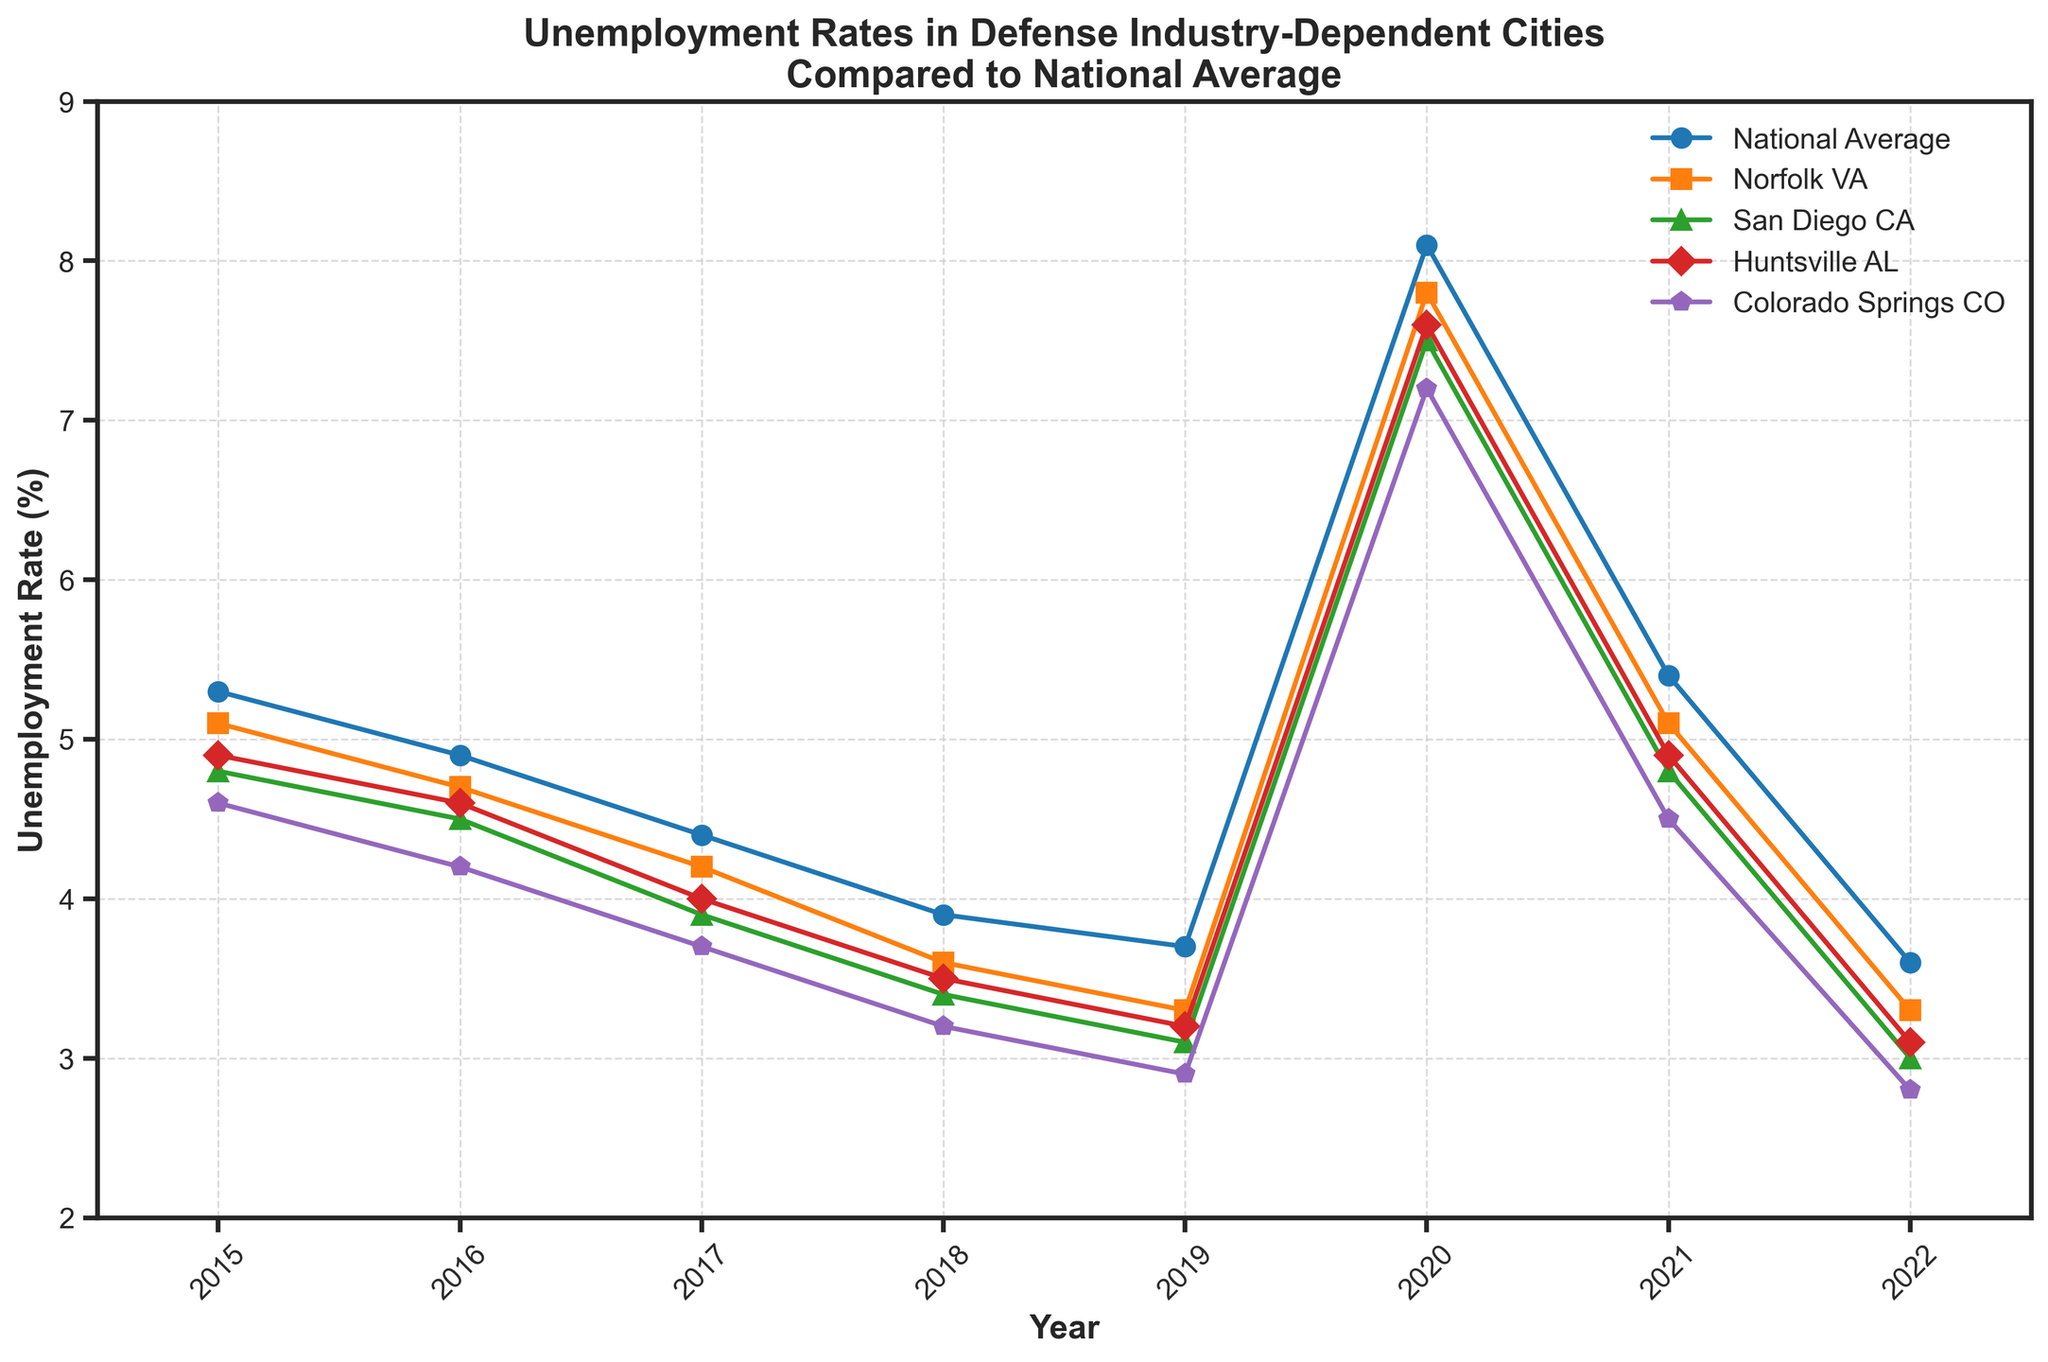What was the unemployment rate in Norfolk, VA in 2020? We look at the unemployment rate for Norfolk, VA on the year 2020 line, which shows 7.8%.
Answer: 7.8% Which city had the lowest unemployment rate in 2022? Comparing the 2022 unemployment rates for all cities, Colorado Springs, CO had the lowest at 2.8%.
Answer: Colorado Springs, CO Was the national average unemployment rate higher or lower than San Diego, CA in 2017? For 2017, the national average was 4.4% and San Diego, CA was 3.9%, so the national average was higher.
Answer: Higher What is the difference in unemployment rates between Huntsville, AL and Norfolk, VA in 2019? The unemployment rates for 2019 were 3.2% for Huntsville, AL and 3.3% for Norfolk, VA. The difference is 3.3% - 3.2% = 0.1%.
Answer: 0.1% How did the unemployment rate for Colorado Springs, CO compare to the national average in 2015? In 2015, the national average was 5.3% and the rate for Colorado Springs, CO was 4.6%. Thus, Colorado Springs, CO had a lower unemployment rate.
Answer: Lower By how much did the unemployment rate for San Diego, CA decrease from 2015 to 2022? San Diego, CA's unemployment rate was 4.8% in 2015 and 3.0% in 2022. The decrease is 4.8% - 3.0% = 1.8%.
Answer: 1.8% Which year showed the highest unemployment rate for all cities? Observing the trends, the year 2020 had the highest unemployment rates for all cities with the national average being 8.1%.
Answer: 2020 Did Huntsville, AL ever have a higher unemployment rate than the national average in the given years? By comparing each year's data, Huntsville, AL's unemployment rate was consistently lower than the national average every year.
Answer: No How does the trend in the unemployment rate from 2015 to 2022 for Norfolk, VA compare to the national average? Both Norfolk, VA and the national average show a general declining trend from 2015 to 2019, a spike in 2020, and a decline again in 2021 and 2022. Norfolk, VA’s rates are consistently below the national average.
Answer: Below 